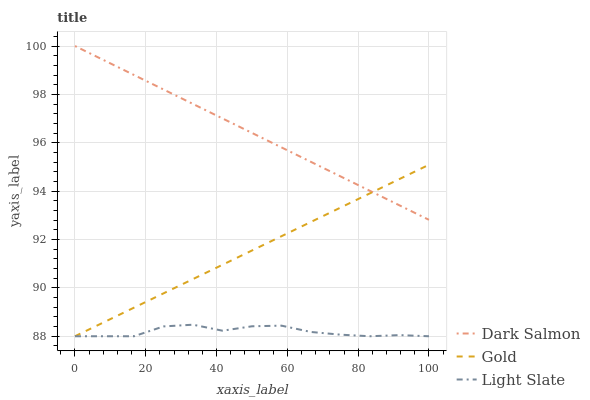Does Light Slate have the minimum area under the curve?
Answer yes or no. Yes. Does Dark Salmon have the maximum area under the curve?
Answer yes or no. Yes. Does Gold have the minimum area under the curve?
Answer yes or no. No. Does Gold have the maximum area under the curve?
Answer yes or no. No. Is Gold the smoothest?
Answer yes or no. Yes. Is Light Slate the roughest?
Answer yes or no. Yes. Is Dark Salmon the smoothest?
Answer yes or no. No. Is Dark Salmon the roughest?
Answer yes or no. No. Does Dark Salmon have the lowest value?
Answer yes or no. No. Does Dark Salmon have the highest value?
Answer yes or no. Yes. Does Gold have the highest value?
Answer yes or no. No. Is Light Slate less than Dark Salmon?
Answer yes or no. Yes. Is Dark Salmon greater than Light Slate?
Answer yes or no. Yes. Does Light Slate intersect Gold?
Answer yes or no. Yes. Is Light Slate less than Gold?
Answer yes or no. No. Is Light Slate greater than Gold?
Answer yes or no. No. Does Light Slate intersect Dark Salmon?
Answer yes or no. No. 